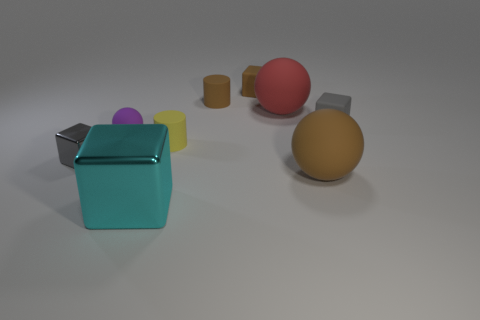There is a ball to the left of the cylinder that is behind the gray rubber cube; what is its color?
Your answer should be compact. Purple. How many cylinders have the same color as the tiny metal object?
Ensure brevity in your answer.  0. Is the color of the tiny metal object the same as the tiny rubber thing to the left of the cyan metallic thing?
Make the answer very short. No. Is the number of blue objects less than the number of small yellow matte cylinders?
Give a very brief answer. Yes. Is the number of large metallic blocks in front of the cyan metal thing greater than the number of tiny purple spheres left of the purple matte object?
Your response must be concise. No. Do the large red ball and the cyan block have the same material?
Your answer should be very brief. No. How many big brown spheres are on the left side of the small gray block left of the big cyan object?
Provide a succinct answer. 0. Do the small cylinder that is on the right side of the tiny yellow object and the small metallic thing have the same color?
Provide a short and direct response. No. What number of objects are either tiny gray shiny cylinders or small gray blocks that are right of the large brown matte sphere?
Provide a succinct answer. 1. Do the small gray object on the left side of the purple matte sphere and the tiny gray thing that is behind the gray metal block have the same shape?
Keep it short and to the point. Yes. 